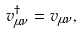Convert formula to latex. <formula><loc_0><loc_0><loc_500><loc_500>v _ { \mu \nu } ^ { \dagger } = v _ { \mu \nu } ,</formula> 